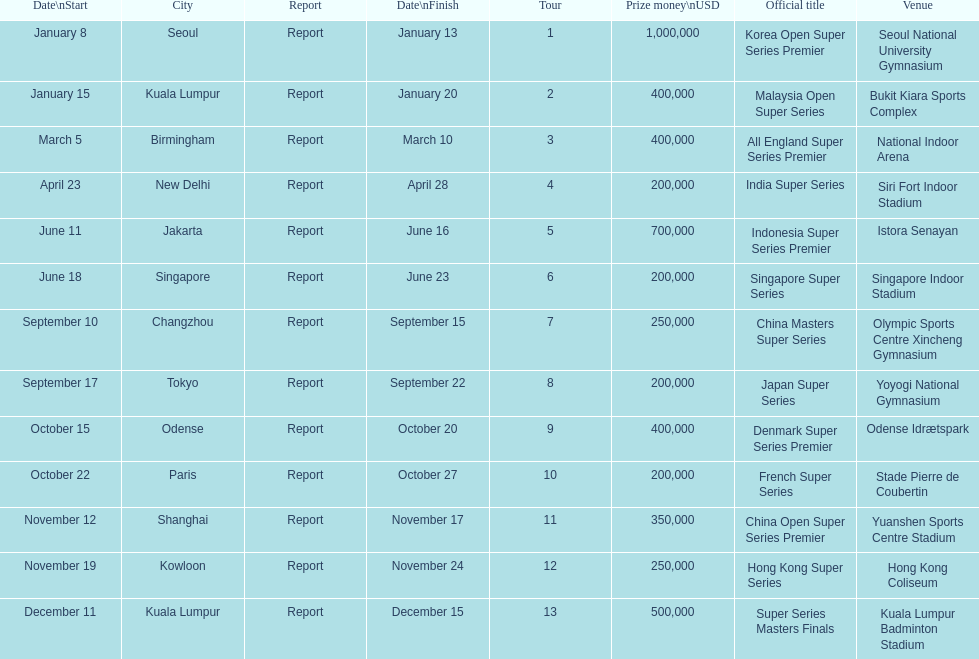How long did the japan super series take? 5 days. 